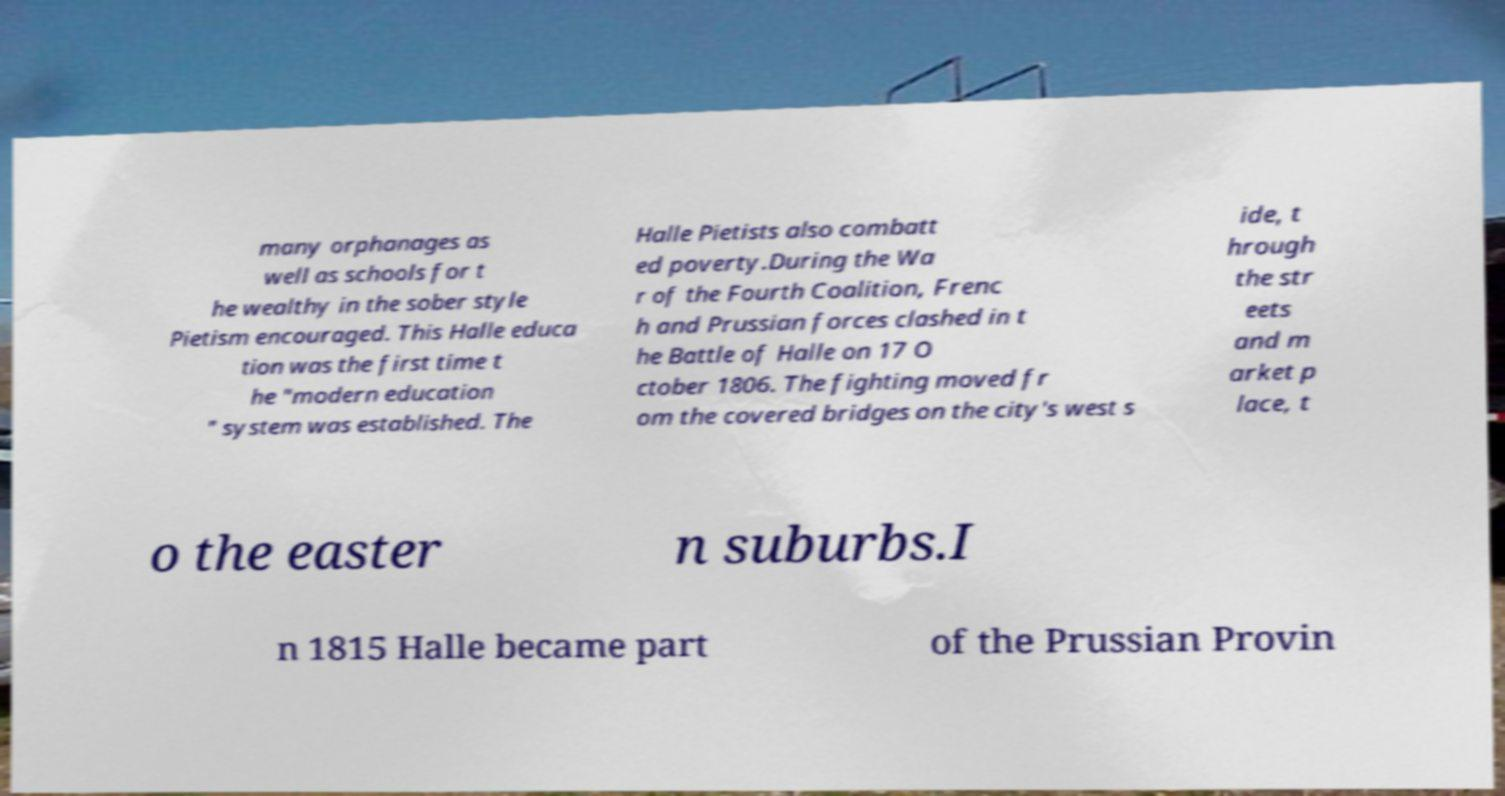I need the written content from this picture converted into text. Can you do that? many orphanages as well as schools for t he wealthy in the sober style Pietism encouraged. This Halle educa tion was the first time t he "modern education " system was established. The Halle Pietists also combatt ed poverty.During the Wa r of the Fourth Coalition, Frenc h and Prussian forces clashed in t he Battle of Halle on 17 O ctober 1806. The fighting moved fr om the covered bridges on the city's west s ide, t hrough the str eets and m arket p lace, t o the easter n suburbs.I n 1815 Halle became part of the Prussian Provin 